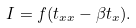Convert formula to latex. <formula><loc_0><loc_0><loc_500><loc_500>I = f ( t _ { x x } - \beta t _ { x } ) .</formula> 